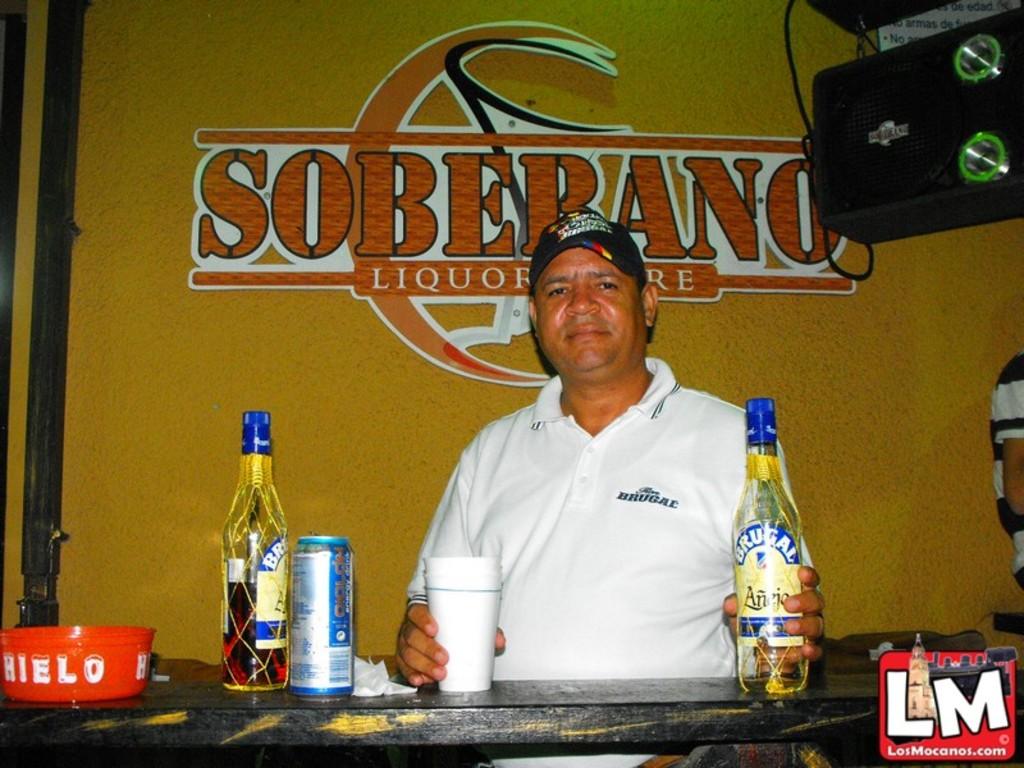What brand of alcohol is displayed on the wall?
Give a very brief answer. Soberano. What are the 2 initials on the bottom right hand corner?
Offer a terse response. Lm. 